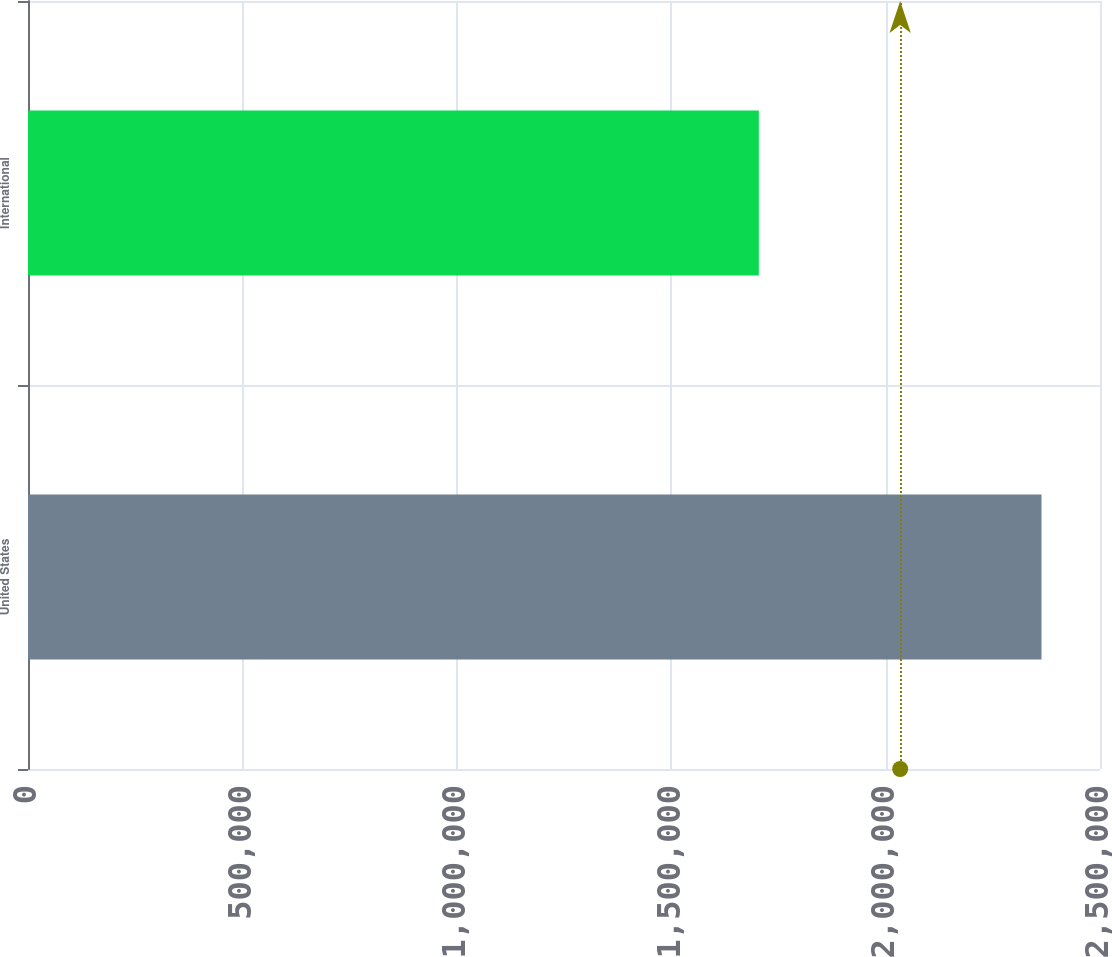<chart> <loc_0><loc_0><loc_500><loc_500><bar_chart><fcel>United States<fcel>International<nl><fcel>2.36356e+06<fcel>1.70439e+06<nl></chart> 